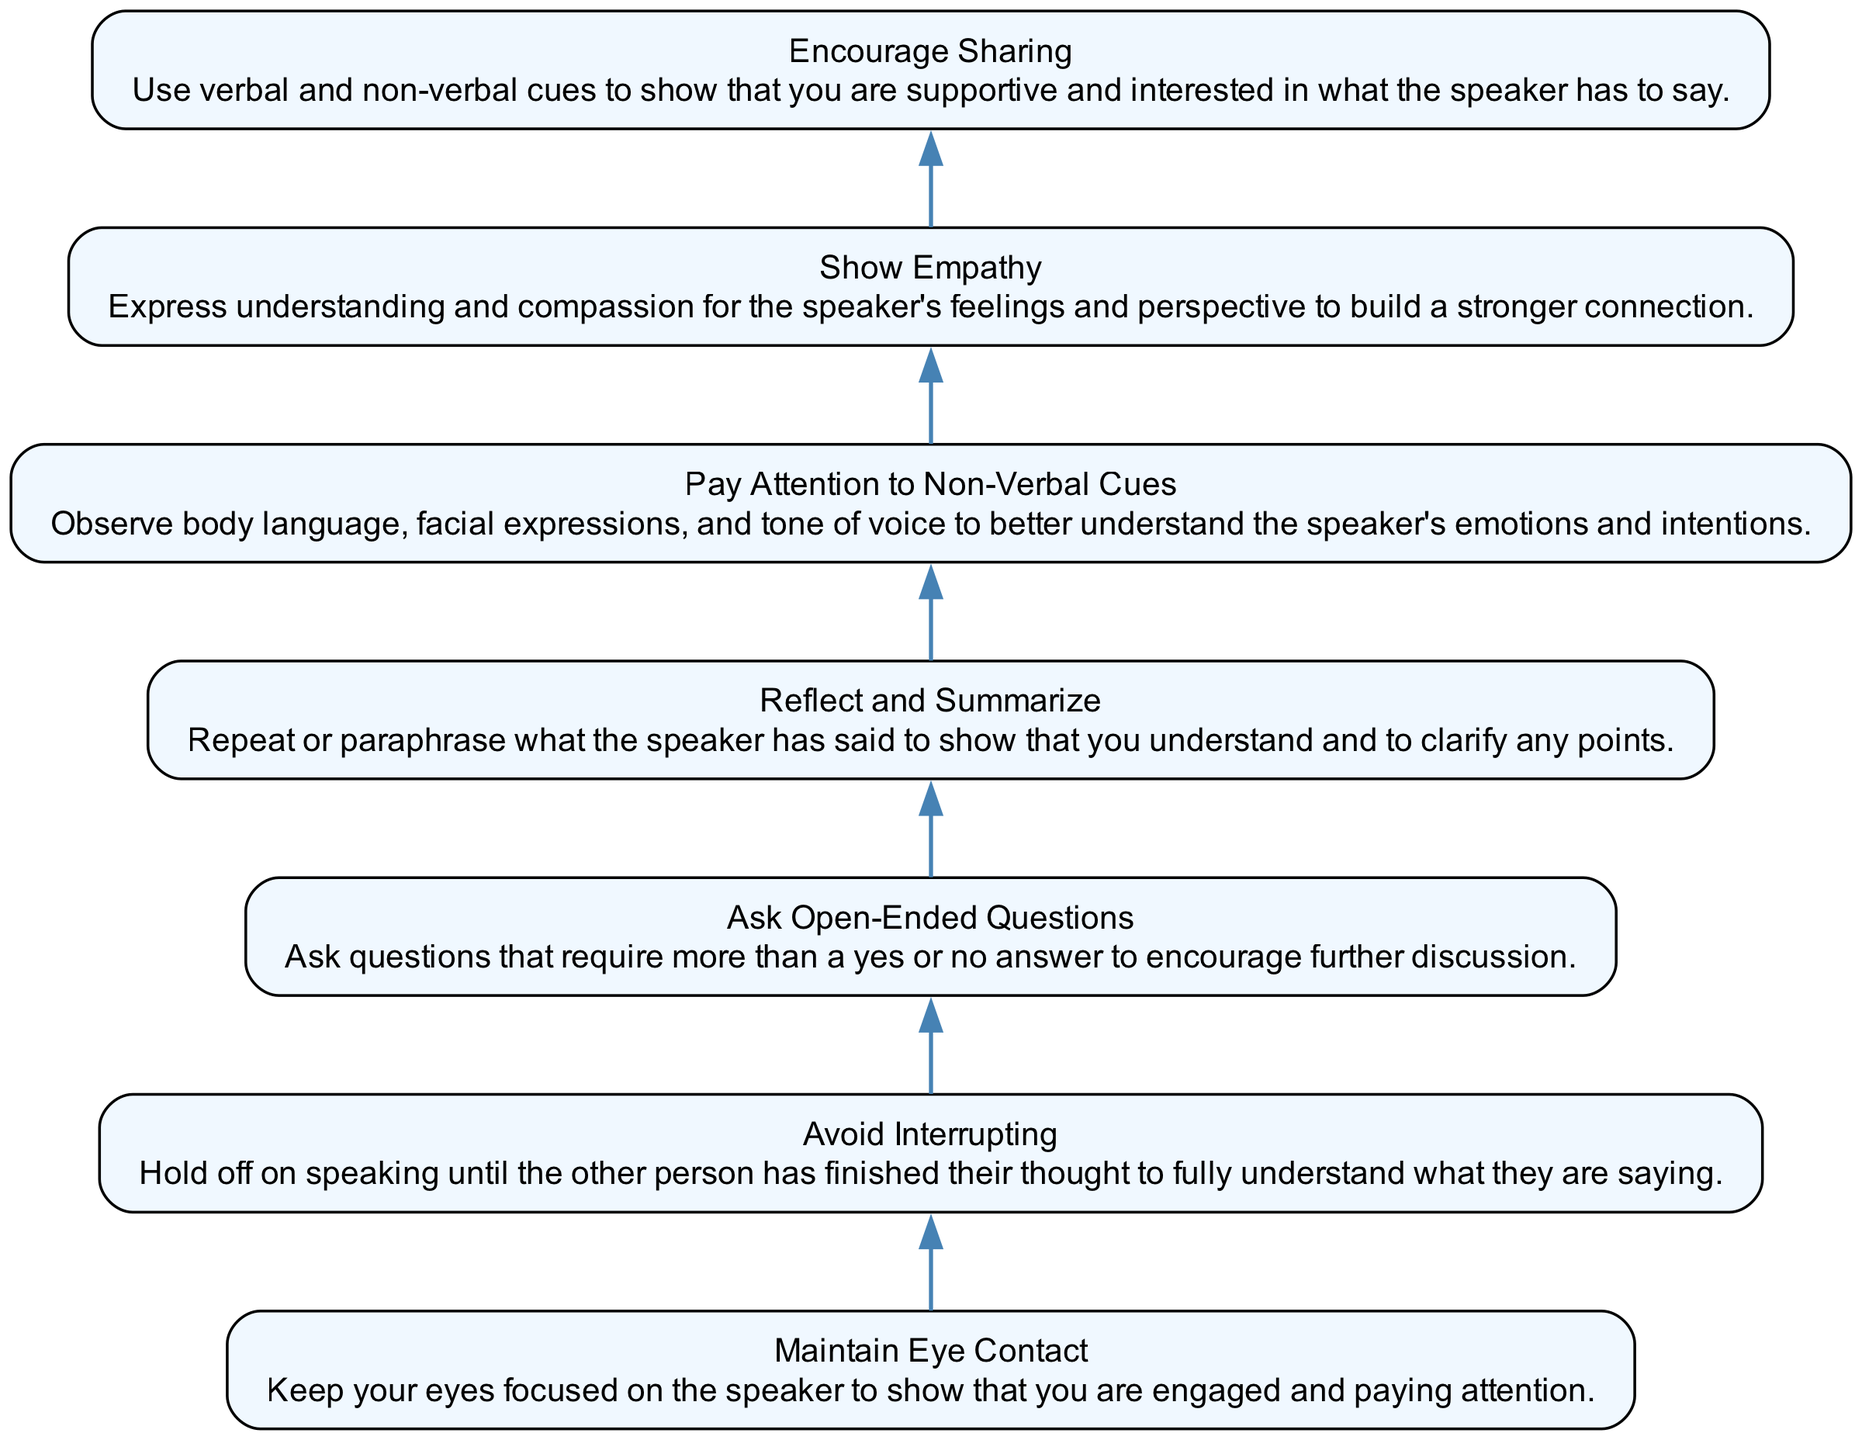What is the first step in improving active listening skills? The diagram presents the steps in a bottom-to-top flow, starting with "Maintain Eye Contact" as the first step.
Answer: Maintain Eye Contact How many steps are there in total to improve active listening skills? Counting each unique step listed in the diagram, there are seven steps outlined for improving active listening skills.
Answer: 7 What is the last step shown in the diagram? The bottom of the diagram indicates the last step in the process, which is "Encourage Sharing."
Answer: Encourage Sharing Which step emphasizes understanding the speaker’s emotions and intentions? The step focused on this aspect is "Pay Attention to Non-Verbal Cues," as it specifically mentions observing body language, facial expressions, and tone of voice.
Answer: Pay Attention to Non-Verbal Cues What is the relationship between "Ask Open-Ended Questions" and "Reflect and Summarize"? Both steps are sequentially connected; "Ask Open-Ended Questions" comes before "Reflect and Summarize," indicating that asking questions leads to summarizing what was heard.
Answer: Sequential connection In which step are empathy and compassion highlighted? The step that highlights empathy and compassion is "Show Empathy," as it explicitly mentions expressing understanding for the speaker's feelings.
Answer: Show Empathy What should you do to encourage the speaker to share more? To encourage sharing, one should "Use verbal and non-verbal cues" to show support and interest in the speaker's message, as per the corresponding step.
Answer: Encourage Sharing 